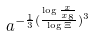<formula> <loc_0><loc_0><loc_500><loc_500>a ^ { - \frac { 1 } { 3 } ( \frac { \log \frac { x } { x _ { 8 } } } { \log \Xi } ) ^ { 3 } }</formula> 